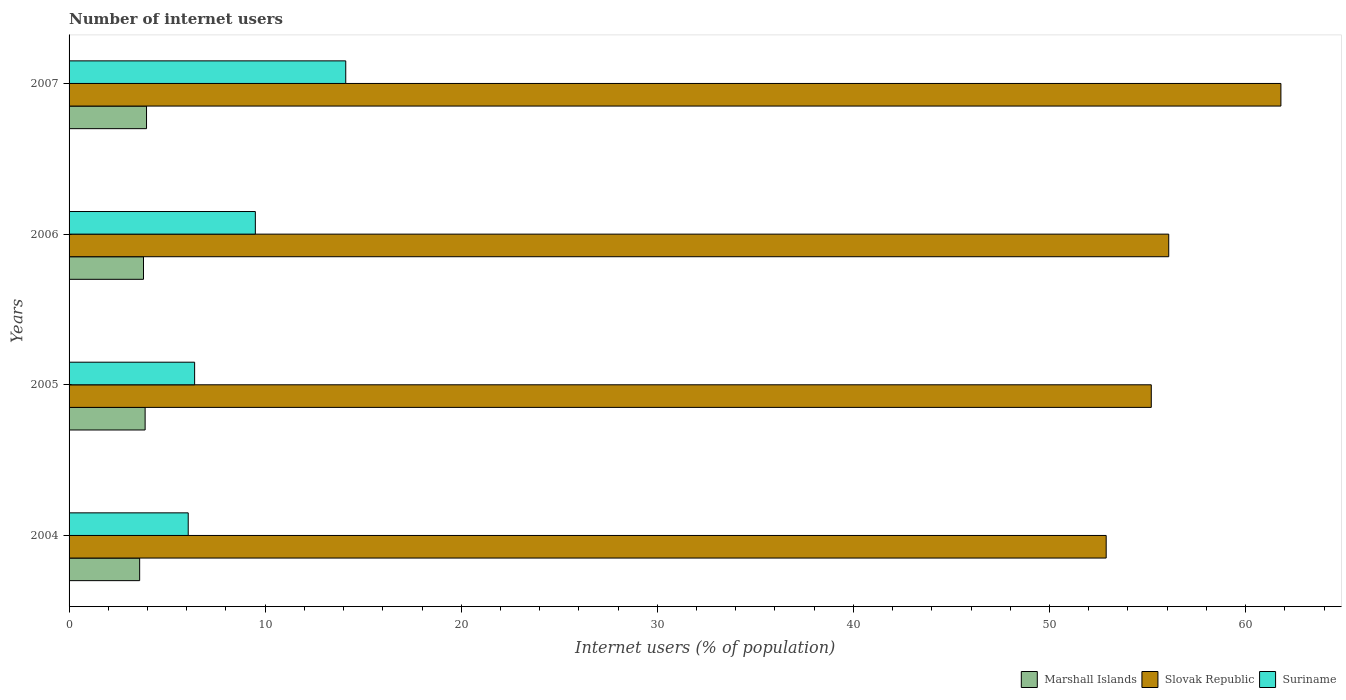How many groups of bars are there?
Keep it short and to the point. 4. Are the number of bars per tick equal to the number of legend labels?
Ensure brevity in your answer.  Yes. Are the number of bars on each tick of the Y-axis equal?
Your answer should be compact. Yes. How many bars are there on the 4th tick from the bottom?
Offer a very short reply. 3. What is the label of the 3rd group of bars from the top?
Offer a terse response. 2005. In how many cases, is the number of bars for a given year not equal to the number of legend labels?
Keep it short and to the point. 0. What is the number of internet users in Slovak Republic in 2007?
Keep it short and to the point. 61.8. Across all years, what is the maximum number of internet users in Marshall Islands?
Your response must be concise. 3.95. Across all years, what is the minimum number of internet users in Suriname?
Provide a succinct answer. 6.08. In which year was the number of internet users in Slovak Republic maximum?
Your answer should be very brief. 2007. In which year was the number of internet users in Marshall Islands minimum?
Keep it short and to the point. 2004. What is the total number of internet users in Slovak Republic in the graph?
Provide a succinct answer. 225.96. What is the difference between the number of internet users in Marshall Islands in 2006 and that in 2007?
Offer a very short reply. -0.15. What is the difference between the number of internet users in Marshall Islands in 2006 and the number of internet users in Slovak Republic in 2005?
Provide a succinct answer. -51.39. What is the average number of internet users in Suriname per year?
Offer a terse response. 9.02. In the year 2005, what is the difference between the number of internet users in Suriname and number of internet users in Slovak Republic?
Make the answer very short. -48.79. What is the ratio of the number of internet users in Slovak Republic in 2005 to that in 2007?
Your answer should be very brief. 0.89. Is the difference between the number of internet users in Suriname in 2006 and 2007 greater than the difference between the number of internet users in Slovak Republic in 2006 and 2007?
Ensure brevity in your answer.  Yes. What is the difference between the highest and the second highest number of internet users in Slovak Republic?
Keep it short and to the point. 5.72. What is the difference between the highest and the lowest number of internet users in Slovak Republic?
Ensure brevity in your answer.  8.91. What does the 3rd bar from the top in 2006 represents?
Ensure brevity in your answer.  Marshall Islands. What does the 1st bar from the bottom in 2004 represents?
Keep it short and to the point. Marshall Islands. How many bars are there?
Your answer should be very brief. 12. What is the difference between two consecutive major ticks on the X-axis?
Keep it short and to the point. 10. Are the values on the major ticks of X-axis written in scientific E-notation?
Provide a succinct answer. No. Does the graph contain any zero values?
Your answer should be very brief. No. Where does the legend appear in the graph?
Your answer should be compact. Bottom right. How many legend labels are there?
Your answer should be compact. 3. What is the title of the graph?
Offer a very short reply. Number of internet users. Does "Solomon Islands" appear as one of the legend labels in the graph?
Your answer should be very brief. No. What is the label or title of the X-axis?
Offer a terse response. Internet users (% of population). What is the label or title of the Y-axis?
Give a very brief answer. Years. What is the Internet users (% of population) in Marshall Islands in 2004?
Offer a terse response. 3.6. What is the Internet users (% of population) of Slovak Republic in 2004?
Offer a very short reply. 52.89. What is the Internet users (% of population) in Suriname in 2004?
Offer a terse response. 6.08. What is the Internet users (% of population) of Marshall Islands in 2005?
Your answer should be very brief. 3.88. What is the Internet users (% of population) in Slovak Republic in 2005?
Provide a succinct answer. 55.19. What is the Internet users (% of population) of Suriname in 2005?
Offer a terse response. 6.4. What is the Internet users (% of population) of Marshall Islands in 2006?
Keep it short and to the point. 3.8. What is the Internet users (% of population) of Slovak Republic in 2006?
Your answer should be compact. 56.08. What is the Internet users (% of population) of Suriname in 2006?
Provide a succinct answer. 9.5. What is the Internet users (% of population) in Marshall Islands in 2007?
Your response must be concise. 3.95. What is the Internet users (% of population) in Slovak Republic in 2007?
Make the answer very short. 61.8. What is the Internet users (% of population) of Suriname in 2007?
Your response must be concise. 14.11. Across all years, what is the maximum Internet users (% of population) in Marshall Islands?
Your answer should be very brief. 3.95. Across all years, what is the maximum Internet users (% of population) in Slovak Republic?
Ensure brevity in your answer.  61.8. Across all years, what is the maximum Internet users (% of population) in Suriname?
Ensure brevity in your answer.  14.11. Across all years, what is the minimum Internet users (% of population) of Marshall Islands?
Keep it short and to the point. 3.6. Across all years, what is the minimum Internet users (% of population) of Slovak Republic?
Ensure brevity in your answer.  52.89. Across all years, what is the minimum Internet users (% of population) of Suriname?
Ensure brevity in your answer.  6.08. What is the total Internet users (% of population) of Marshall Islands in the graph?
Offer a terse response. 15.22. What is the total Internet users (% of population) in Slovak Republic in the graph?
Your answer should be very brief. 225.96. What is the total Internet users (% of population) in Suriname in the graph?
Offer a very short reply. 36.09. What is the difference between the Internet users (% of population) in Marshall Islands in 2004 and that in 2005?
Provide a short and direct response. -0.28. What is the difference between the Internet users (% of population) in Slovak Republic in 2004 and that in 2005?
Keep it short and to the point. -2.3. What is the difference between the Internet users (% of population) of Suriname in 2004 and that in 2005?
Make the answer very short. -0.33. What is the difference between the Internet users (% of population) of Marshall Islands in 2004 and that in 2006?
Ensure brevity in your answer.  -0.2. What is the difference between the Internet users (% of population) in Slovak Republic in 2004 and that in 2006?
Give a very brief answer. -3.19. What is the difference between the Internet users (% of population) in Suriname in 2004 and that in 2006?
Offer a terse response. -3.42. What is the difference between the Internet users (% of population) of Marshall Islands in 2004 and that in 2007?
Provide a short and direct response. -0.35. What is the difference between the Internet users (% of population) of Slovak Republic in 2004 and that in 2007?
Your response must be concise. -8.91. What is the difference between the Internet users (% of population) of Suriname in 2004 and that in 2007?
Keep it short and to the point. -8.03. What is the difference between the Internet users (% of population) in Marshall Islands in 2005 and that in 2006?
Provide a succinct answer. 0.08. What is the difference between the Internet users (% of population) of Slovak Republic in 2005 and that in 2006?
Keep it short and to the point. -0.89. What is the difference between the Internet users (% of population) of Suriname in 2005 and that in 2006?
Give a very brief answer. -3.1. What is the difference between the Internet users (% of population) of Marshall Islands in 2005 and that in 2007?
Your response must be concise. -0.07. What is the difference between the Internet users (% of population) in Slovak Republic in 2005 and that in 2007?
Provide a succinct answer. -6.61. What is the difference between the Internet users (% of population) in Suriname in 2005 and that in 2007?
Offer a very short reply. -7.71. What is the difference between the Internet users (% of population) of Marshall Islands in 2006 and that in 2007?
Provide a short and direct response. -0.15. What is the difference between the Internet users (% of population) of Slovak Republic in 2006 and that in 2007?
Keep it short and to the point. -5.72. What is the difference between the Internet users (% of population) of Suriname in 2006 and that in 2007?
Offer a terse response. -4.61. What is the difference between the Internet users (% of population) in Marshall Islands in 2004 and the Internet users (% of population) in Slovak Republic in 2005?
Ensure brevity in your answer.  -51.59. What is the difference between the Internet users (% of population) in Marshall Islands in 2004 and the Internet users (% of population) in Suriname in 2005?
Your response must be concise. -2.8. What is the difference between the Internet users (% of population) of Slovak Republic in 2004 and the Internet users (% of population) of Suriname in 2005?
Keep it short and to the point. 46.49. What is the difference between the Internet users (% of population) of Marshall Islands in 2004 and the Internet users (% of population) of Slovak Republic in 2006?
Make the answer very short. -52.48. What is the difference between the Internet users (% of population) in Marshall Islands in 2004 and the Internet users (% of population) in Suriname in 2006?
Provide a succinct answer. -5.9. What is the difference between the Internet users (% of population) of Slovak Republic in 2004 and the Internet users (% of population) of Suriname in 2006?
Make the answer very short. 43.39. What is the difference between the Internet users (% of population) of Marshall Islands in 2004 and the Internet users (% of population) of Slovak Republic in 2007?
Give a very brief answer. -58.2. What is the difference between the Internet users (% of population) in Marshall Islands in 2004 and the Internet users (% of population) in Suriname in 2007?
Ensure brevity in your answer.  -10.51. What is the difference between the Internet users (% of population) of Slovak Republic in 2004 and the Internet users (% of population) of Suriname in 2007?
Keep it short and to the point. 38.78. What is the difference between the Internet users (% of population) in Marshall Islands in 2005 and the Internet users (% of population) in Slovak Republic in 2006?
Keep it short and to the point. -52.2. What is the difference between the Internet users (% of population) of Marshall Islands in 2005 and the Internet users (% of population) of Suriname in 2006?
Provide a short and direct response. -5.62. What is the difference between the Internet users (% of population) in Slovak Republic in 2005 and the Internet users (% of population) in Suriname in 2006?
Your response must be concise. 45.69. What is the difference between the Internet users (% of population) in Marshall Islands in 2005 and the Internet users (% of population) in Slovak Republic in 2007?
Give a very brief answer. -57.92. What is the difference between the Internet users (% of population) of Marshall Islands in 2005 and the Internet users (% of population) of Suriname in 2007?
Provide a succinct answer. -10.23. What is the difference between the Internet users (% of population) of Slovak Republic in 2005 and the Internet users (% of population) of Suriname in 2007?
Your answer should be very brief. 41.08. What is the difference between the Internet users (% of population) of Marshall Islands in 2006 and the Internet users (% of population) of Slovak Republic in 2007?
Make the answer very short. -58. What is the difference between the Internet users (% of population) in Marshall Islands in 2006 and the Internet users (% of population) in Suriname in 2007?
Offer a very short reply. -10.31. What is the difference between the Internet users (% of population) in Slovak Republic in 2006 and the Internet users (% of population) in Suriname in 2007?
Your answer should be very brief. 41.97. What is the average Internet users (% of population) in Marshall Islands per year?
Your answer should be very brief. 3.81. What is the average Internet users (% of population) of Slovak Republic per year?
Keep it short and to the point. 56.49. What is the average Internet users (% of population) of Suriname per year?
Give a very brief answer. 9.02. In the year 2004, what is the difference between the Internet users (% of population) of Marshall Islands and Internet users (% of population) of Slovak Republic?
Your answer should be very brief. -49.29. In the year 2004, what is the difference between the Internet users (% of population) in Marshall Islands and Internet users (% of population) in Suriname?
Offer a terse response. -2.48. In the year 2004, what is the difference between the Internet users (% of population) in Slovak Republic and Internet users (% of population) in Suriname?
Give a very brief answer. 46.81. In the year 2005, what is the difference between the Internet users (% of population) of Marshall Islands and Internet users (% of population) of Slovak Republic?
Offer a terse response. -51.31. In the year 2005, what is the difference between the Internet users (% of population) of Marshall Islands and Internet users (% of population) of Suriname?
Ensure brevity in your answer.  -2.52. In the year 2005, what is the difference between the Internet users (% of population) of Slovak Republic and Internet users (% of population) of Suriname?
Your answer should be very brief. 48.79. In the year 2006, what is the difference between the Internet users (% of population) in Marshall Islands and Internet users (% of population) in Slovak Republic?
Make the answer very short. -52.28. In the year 2006, what is the difference between the Internet users (% of population) of Marshall Islands and Internet users (% of population) of Suriname?
Provide a short and direct response. -5.7. In the year 2006, what is the difference between the Internet users (% of population) in Slovak Republic and Internet users (% of population) in Suriname?
Ensure brevity in your answer.  46.58. In the year 2007, what is the difference between the Internet users (% of population) in Marshall Islands and Internet users (% of population) in Slovak Republic?
Offer a terse response. -57.85. In the year 2007, what is the difference between the Internet users (% of population) of Marshall Islands and Internet users (% of population) of Suriname?
Provide a short and direct response. -10.16. In the year 2007, what is the difference between the Internet users (% of population) of Slovak Republic and Internet users (% of population) of Suriname?
Offer a very short reply. 47.69. What is the ratio of the Internet users (% of population) in Marshall Islands in 2004 to that in 2005?
Keep it short and to the point. 0.93. What is the ratio of the Internet users (% of population) in Slovak Republic in 2004 to that in 2005?
Make the answer very short. 0.96. What is the ratio of the Internet users (% of population) in Suriname in 2004 to that in 2005?
Provide a short and direct response. 0.95. What is the ratio of the Internet users (% of population) of Marshall Islands in 2004 to that in 2006?
Offer a very short reply. 0.95. What is the ratio of the Internet users (% of population) in Slovak Republic in 2004 to that in 2006?
Your answer should be very brief. 0.94. What is the ratio of the Internet users (% of population) of Suriname in 2004 to that in 2006?
Offer a terse response. 0.64. What is the ratio of the Internet users (% of population) of Marshall Islands in 2004 to that in 2007?
Your answer should be very brief. 0.91. What is the ratio of the Internet users (% of population) in Slovak Republic in 2004 to that in 2007?
Your response must be concise. 0.86. What is the ratio of the Internet users (% of population) of Suriname in 2004 to that in 2007?
Offer a terse response. 0.43. What is the ratio of the Internet users (% of population) in Marshall Islands in 2005 to that in 2006?
Provide a short and direct response. 1.02. What is the ratio of the Internet users (% of population) of Slovak Republic in 2005 to that in 2006?
Keep it short and to the point. 0.98. What is the ratio of the Internet users (% of population) of Suriname in 2005 to that in 2006?
Provide a short and direct response. 0.67. What is the ratio of the Internet users (% of population) of Marshall Islands in 2005 to that in 2007?
Keep it short and to the point. 0.98. What is the ratio of the Internet users (% of population) of Slovak Republic in 2005 to that in 2007?
Offer a very short reply. 0.89. What is the ratio of the Internet users (% of population) in Suriname in 2005 to that in 2007?
Give a very brief answer. 0.45. What is the ratio of the Internet users (% of population) in Marshall Islands in 2006 to that in 2007?
Your response must be concise. 0.96. What is the ratio of the Internet users (% of population) in Slovak Republic in 2006 to that in 2007?
Your response must be concise. 0.91. What is the ratio of the Internet users (% of population) of Suriname in 2006 to that in 2007?
Provide a short and direct response. 0.67. What is the difference between the highest and the second highest Internet users (% of population) in Marshall Islands?
Keep it short and to the point. 0.07. What is the difference between the highest and the second highest Internet users (% of population) in Slovak Republic?
Your answer should be very brief. 5.72. What is the difference between the highest and the second highest Internet users (% of population) of Suriname?
Give a very brief answer. 4.61. What is the difference between the highest and the lowest Internet users (% of population) in Marshall Islands?
Offer a terse response. 0.35. What is the difference between the highest and the lowest Internet users (% of population) in Slovak Republic?
Your response must be concise. 8.91. What is the difference between the highest and the lowest Internet users (% of population) in Suriname?
Your answer should be very brief. 8.03. 